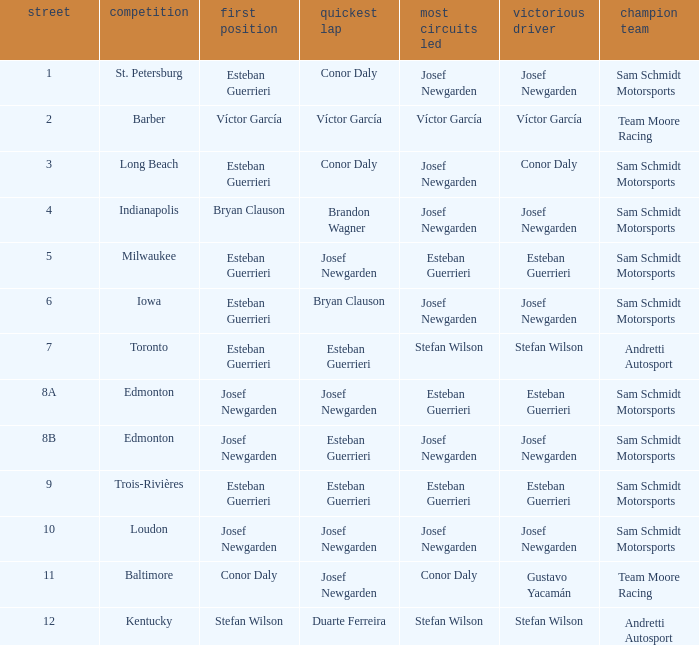Who had the pole(s) when esteban guerrieri led the most laps round 8a and josef newgarden had the fastest lap? Josef Newgarden. 